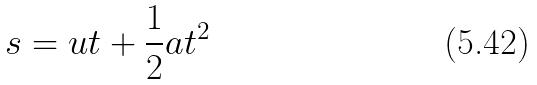Convert formula to latex. <formula><loc_0><loc_0><loc_500><loc_500>s = u t + \frac { 1 } { 2 } a t ^ { 2 }</formula> 